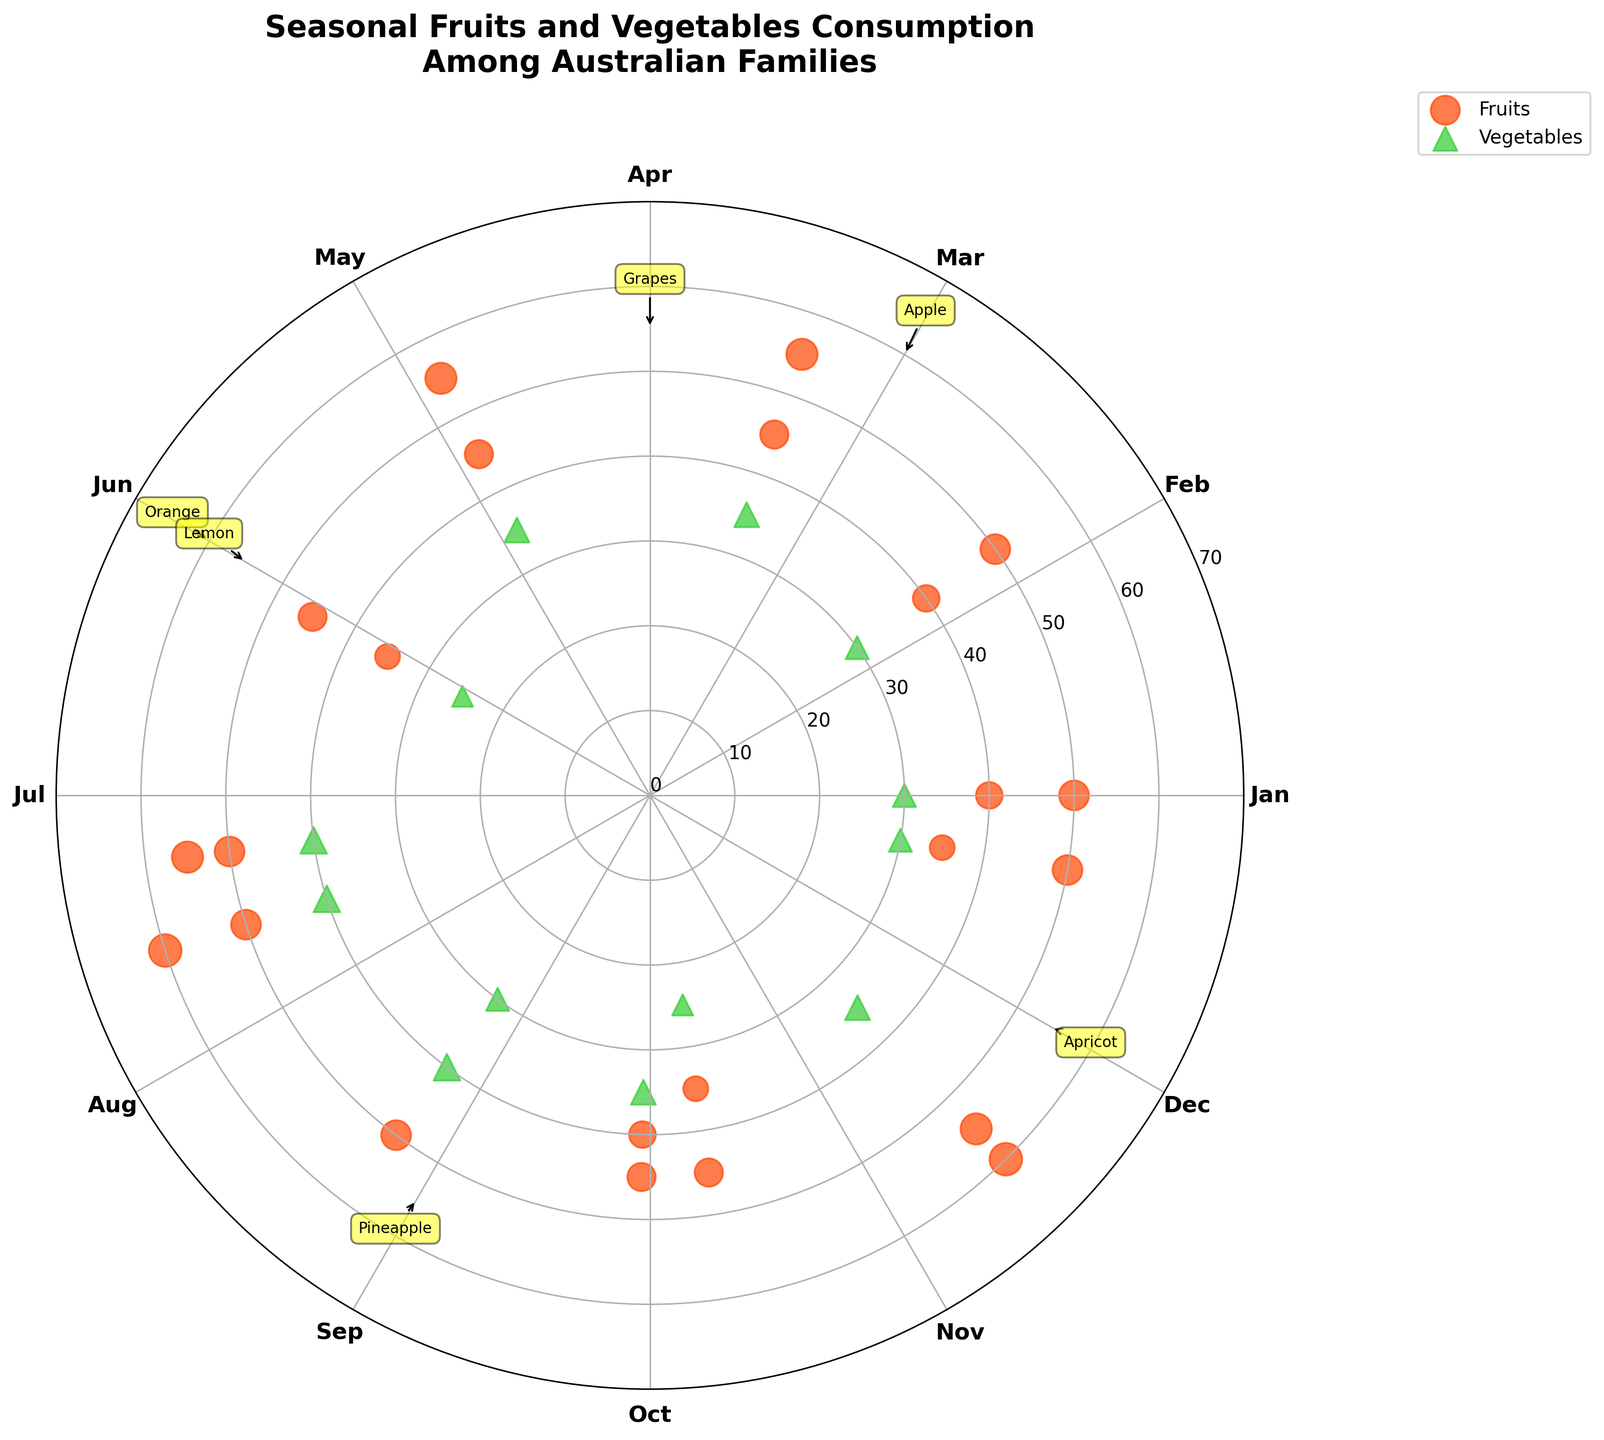Which month has the highest consumption of Apples? March has a consumption of 60 units of Apples, which is highlighted in the plot and mentioned with an annotation.
Answer: March Which vegetable was consumed the most in July? In July, Carrot is the most consumed vegetable with a quantity of 40 units, as indicated by the size of the scatter point in the plot.
Answer: Carrot During which month was the quantity of Mango consumed highest? The highest quantity of Mango consumed is in January, as shown by the data point at 40 units on the plot for January.
Answer: January Sum of the quantities of vegetables consumed in June and November? In June, the vegetables are Cauliflower (35 units), while in November, they are Bell Pepper (35 units). Summing these gives 35 + 35 = 70 units.
Answer: 70 Compare the consumption of Peaches and Plums in February. Which was consumed more? In February, the plot shows the quantity of Peach as 35 units and Plum as 45 units, so Plum was consumed more.
Answer: Plum What is the median consumption value for vegetables throughout the year? The vegetables' consumption values are Zucchini (30), Tomato (25), Broccoli (40), Spinach (35), Pumpkin (30), Cauliflower (35), Carrot (40), Cabbage (30), Beetroot (25), Lettuce (35), Asparagus (30), Bell Pepper (35), and Green Bean (40). Arranging these values: 25, 25, 30, 30, 30, 30, 35, 35, 35, 35, 40, 40, 40; the median value (7th in list) is 35.
Answer: 35 Compare the quantity of fruit consumption during summer (Dec-Feb) vs. winter (Jun-Aug). Which season had higher consumption? Summer fruit consumption: Dec (Apricot 55, Nectarine 50), Jan (Mango 40, Watermelon 50), Feb (Peach 35, Plum 45), total = 275 units. Winter fruit: Jun (Orange 60, Lemon 55), Jul (Banana 50), Aug (Strawberry 45, Blueberry 35), total = 245 units. Summer had higher.
Answer: Summer How many fruits and vegetables have a quantity greater than or equal to 55? The items with quantity >= 55 are Apple (60), Grapes (55), Orange (60), Pineapple (55), and Apricot (55), making it a total of 5 items.
Answer: 5 